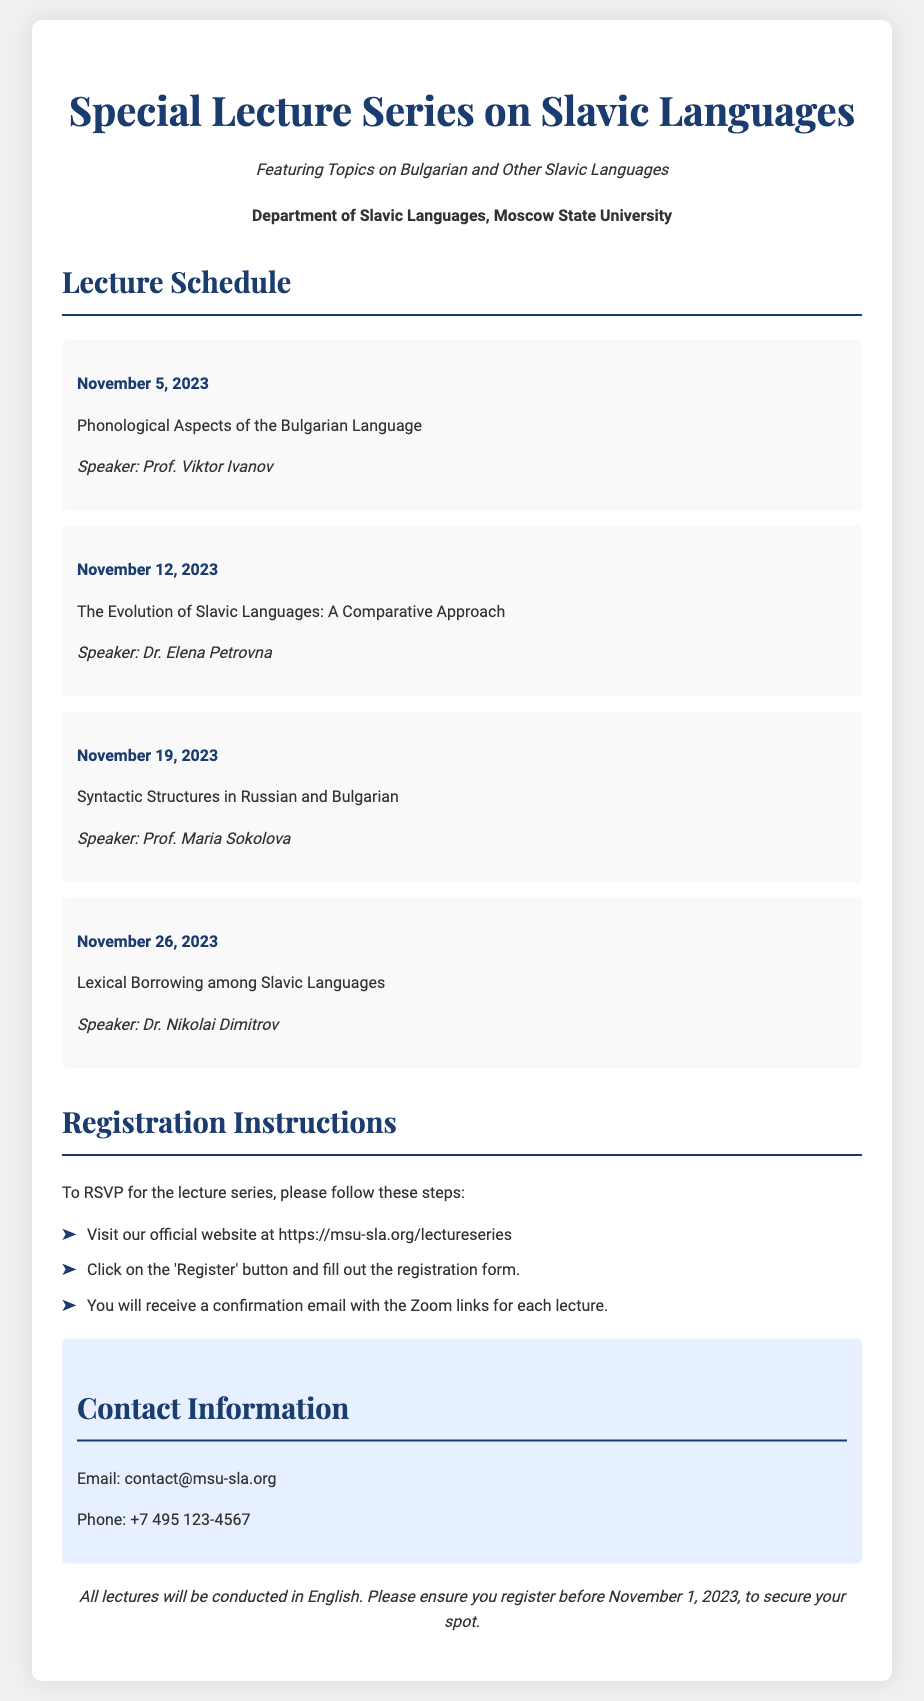What is the first lecture date? The first lecture is scheduled for November 5, 2023, which is mentioned in the lecture schedule section of the document.
Answer: November 5, 2023 Who is the speaker for the second lecture? The second lecture on the evolution of Slavic languages is presented by Dr. Elena Petrovna, as indicated in the document.
Answer: Dr. Elena Petrovna What is the topic of the third lecture? The topic of the third lecture is "Syntactic Structures in Russian and Bulgarian," which is specified in the lecture details.
Answer: Syntactic Structures in Russian and Bulgarian What are the registration instructions? The registration instructions include visiting the website, clicking on the 'Register' button, and filling out the registration form, which outlines the process in the document.
Answer: Visit our official website at https://msu-sla.org/lectureseries When is the registration deadline? The document clearly states that the registration must be completed before November 1, 2023, which defines the deadline for participants.
Answer: November 1, 2023 What is the phone contact for the event? The phone number provided for contact regarding the event is listed in the contact information section of the document.
Answer: +7 495 123-4567 Which university organizes this lecture series? The document states that the lecture series is organized by the Department of Slavic Languages, Moscow State University, highlighting the organizing institution.
Answer: Moscow State University What will be the medium of instruction for the lectures? The additional info section specifies that all lectures will be conducted in English, clarifying the language of instruction.
Answer: English 